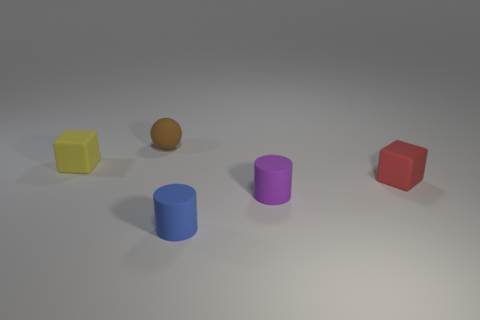Add 1 small metallic blocks. How many objects exist? 6 Subtract 1 cylinders. How many cylinders are left? 1 Subtract all cylinders. How many objects are left? 3 Subtract all red cylinders. Subtract all brown cubes. How many cylinders are left? 2 Subtract all blue cubes. How many blue cylinders are left? 1 Subtract all small brown objects. Subtract all tiny green matte objects. How many objects are left? 4 Add 3 purple things. How many purple things are left? 4 Add 1 green metallic cubes. How many green metallic cubes exist? 1 Subtract 0 gray cubes. How many objects are left? 5 